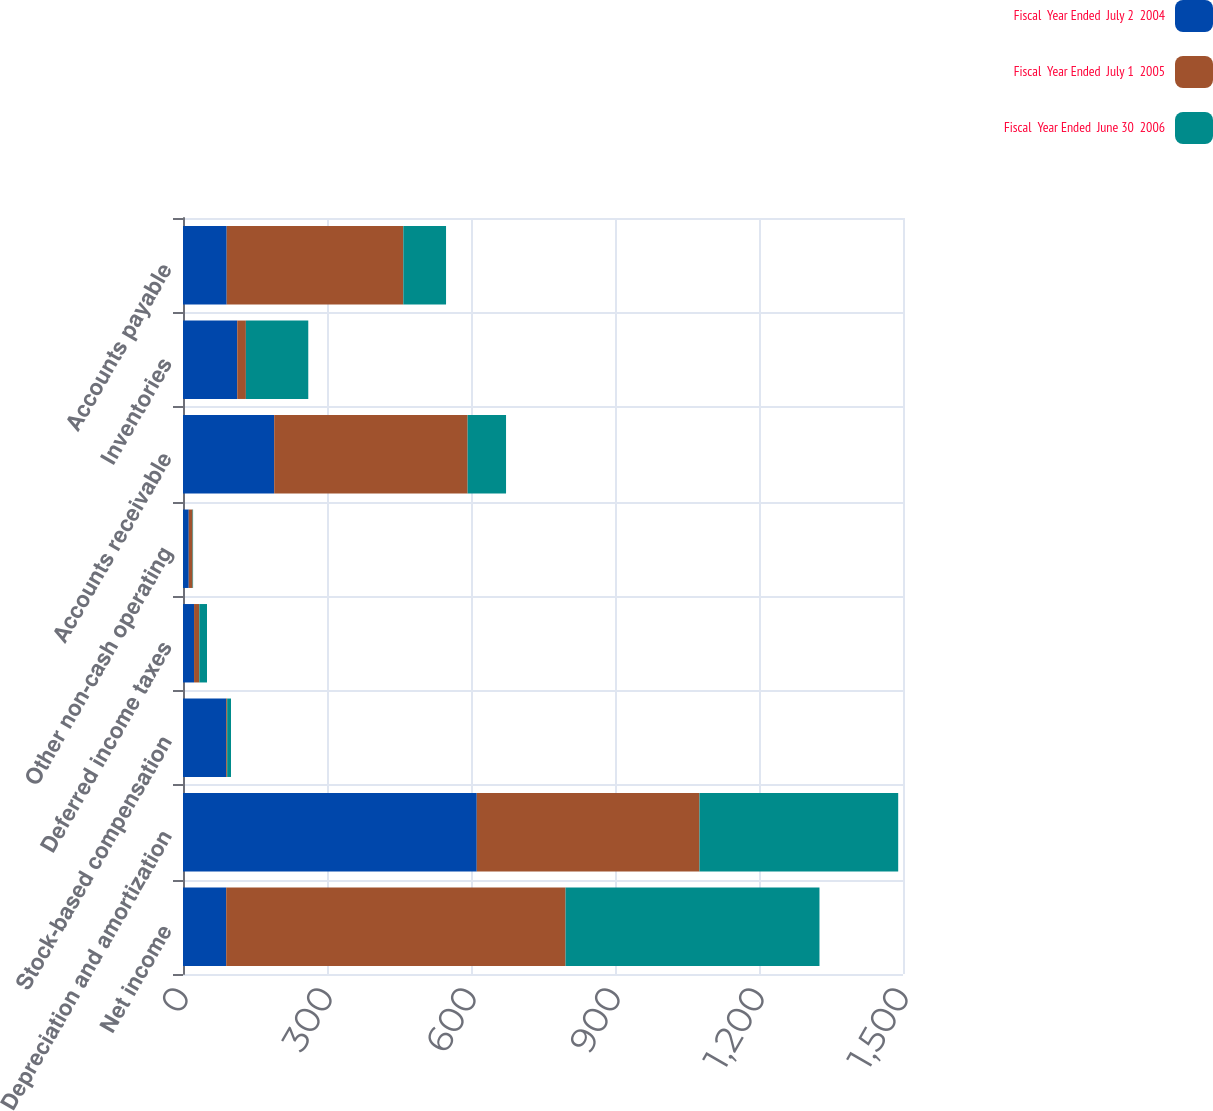Convert chart to OTSL. <chart><loc_0><loc_0><loc_500><loc_500><stacked_bar_chart><ecel><fcel>Net income<fcel>Depreciation and amortization<fcel>Stock-based compensation<fcel>Deferred income taxes<fcel>Other non-cash operating<fcel>Accounts receivable<fcel>Inventories<fcel>Accounts payable<nl><fcel>Fiscal  Year Ended  July 2  2004<fcel>90<fcel>612<fcel>90<fcel>23<fcel>12<fcel>190<fcel>113<fcel>91<nl><fcel>Fiscal  Year Ended  July 1  2005<fcel>707<fcel>464<fcel>2<fcel>11<fcel>8<fcel>403<fcel>18<fcel>368<nl><fcel>Fiscal  Year Ended  June 30  2006<fcel>529<fcel>414<fcel>8<fcel>16<fcel>1<fcel>80<fcel>130<fcel>89<nl></chart> 